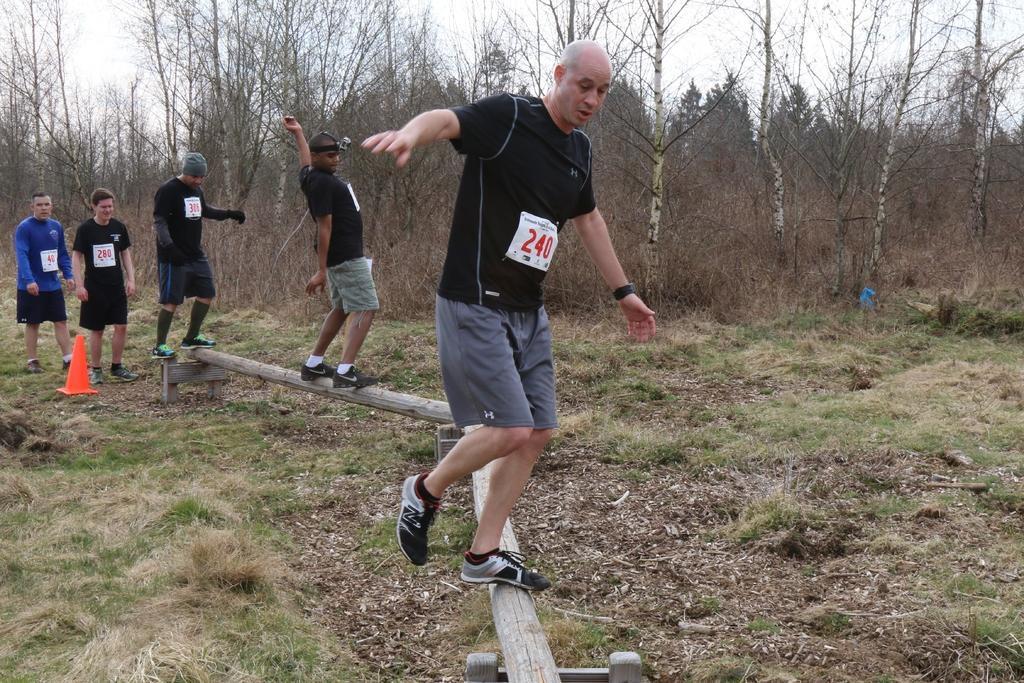Can you describe this image briefly? In this image there is a land, on that land there is log, on that log three men are walking and two men are standing, in the background there are trees. 